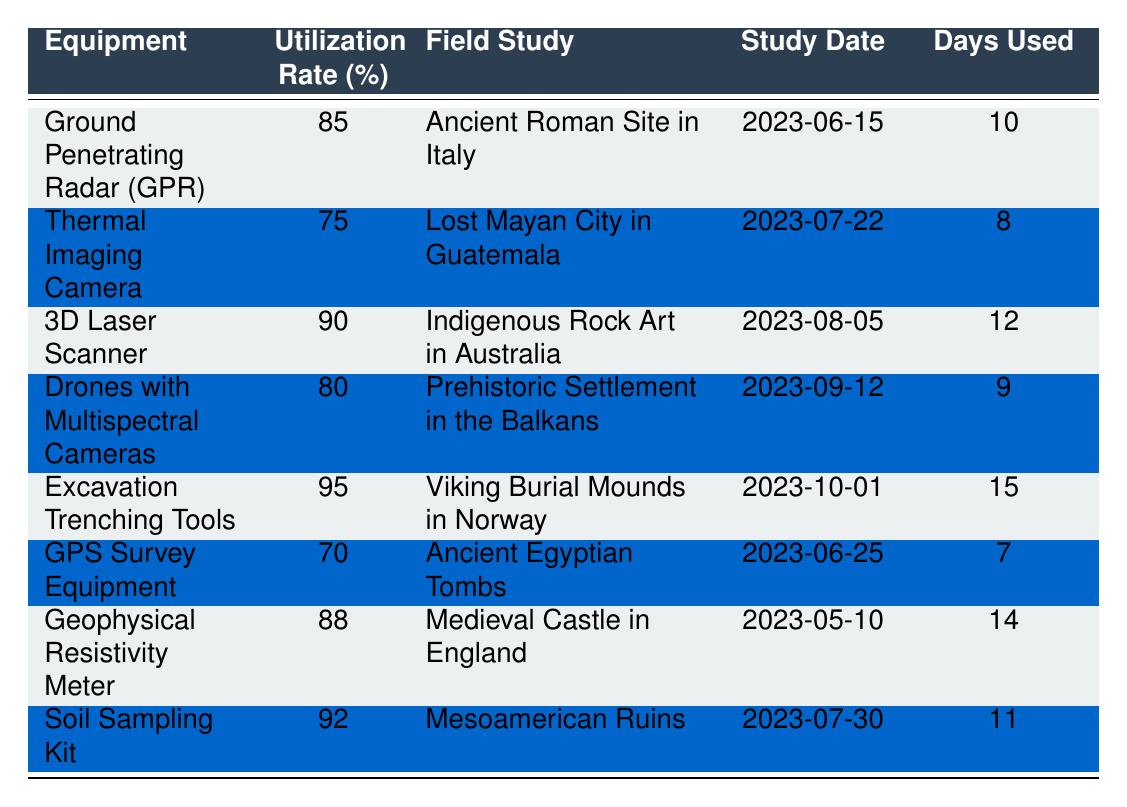What is the utilization rate of the GPS Survey Equipment? The GPS Survey Equipment has a listed utilization rate percent of 70 according to the table.
Answer: 70 Which equipment was utilized for the longest number of days? The Excavation Trenching Tools were used for 15 days, which is the highest number compared to other equipment listed.
Answer: Excavation Trenching Tools Is the utilization rate of the Thermal Imaging Camera higher than 80 percent? The Thermal Imaging Camera has a utilization rate of 75 percent, which is less than 80 percent.
Answer: No What is the average utilization rate of equipment used in field studies? The utilization rates are 85, 75, 90, 80, 95, 70, 88, and 92. The sum is 700, and there are 8 data points, so the average is 700/8 = 87.5 percent.
Answer: 87.5 For which field study was the 3D Laser Scanner used? The 3D Laser Scanner was utilized in the field study at the Indigenous Rock Art in Australia.
Answer: Indigenous Rock Art in Australia Which equipment had a utilization rate of 95 percent? The equipment with a utilization rate of 95 percent is the Excavation Trenching Tools, as indicated in the table.
Answer: Excavation Trenching Tools Was the Geophysical Resistivity Meter used for more days than the Thermal Imaging Camera? The Geophysical Resistivity Meter was used for 14 days while the Thermal Imaging Camera was used for 8 days. Since 14 is greater than 8, it confirms that the Geophysical Resistivity Meter was used for more days.
Answer: Yes What is the difference in utilization rate between the Ground Penetrating Radar and the Excavation Trenching Tools? The Ground Penetrating Radar has a utilization rate of 85 percent, while the Excavation Trenching Tools have a rate of 95 percent. The difference is 95 - 85 = 10 percent.
Answer: 10 percent How many field studies reported a utilization rate greater than 85 percent? The equipment with utilization rates greater than 85 percent are the Ground Penetrating Radar (85), 3D Laser Scanner (90), Excavation Trenching Tools (95), Geophysical Resistivity Meter (88), and Soil Sampling Kit (92). That adds up to 5 studies.
Answer: 5 